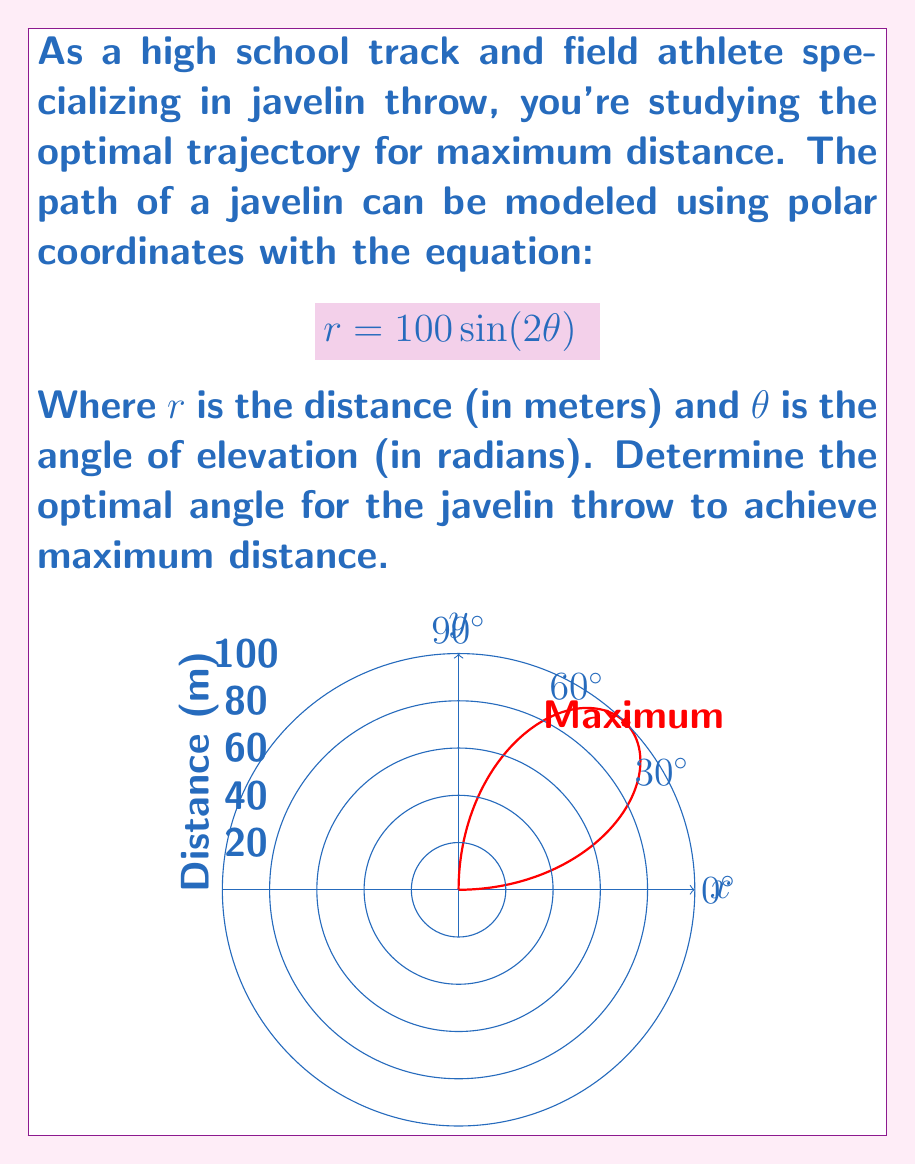Can you solve this math problem? Let's approach this step-by-step:

1) To find the maximum distance, we need to find the maximum value of $r$. In polar coordinates, this occurs at the point furthest from the origin.

2) The maximum of $r = 100\sin(2\theta)$ will occur when $\sin(2\theta)$ is at its maximum.

3) We know that the maximum value of sine is 1, which occurs when its argument is $\frac{\pi}{2}$ (or 90°).

4) So, we need to solve:

   $$2\theta = \frac{\pi}{2}$$

5) Solving for $\theta$:

   $$\theta = \frac{\pi}{4}$$

6) Converting to degrees:

   $$\theta = \frac{\pi}{4} \cdot \frac{180°}{\pi} = 45°$$

7) Therefore, the optimal angle for the javelin throw is 45° or $\frac{\pi}{4}$ radians.

8) At this angle, the maximum distance can be calculated:

   $$r = 100\sin(2 \cdot \frac{\pi}{4}) = 100\sin(\frac{\pi}{2}) = 100$$ meters

This result aligns with the physics principle that, neglecting air resistance, a 45° launch angle maximizes the range of a projectile.
Answer: $45°$ or $\frac{\pi}{4}$ radians 